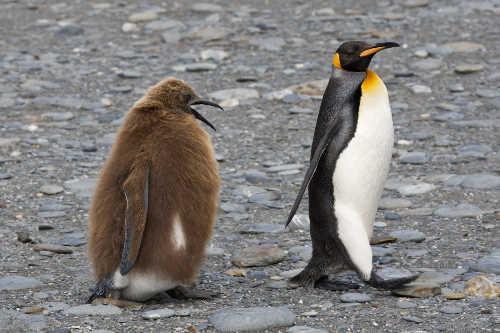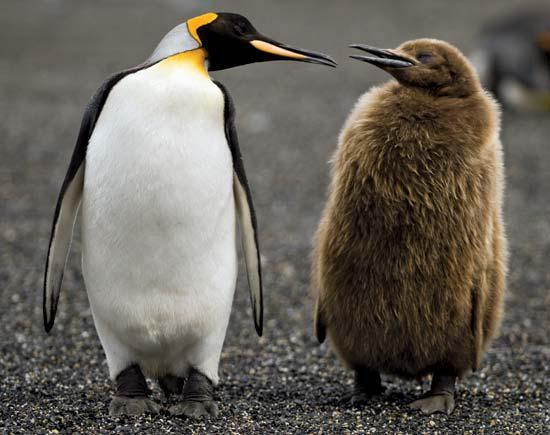The first image is the image on the left, the second image is the image on the right. Considering the images on both sides, is "There are at most 4 penguins total in both images." valid? Answer yes or no. Yes. 